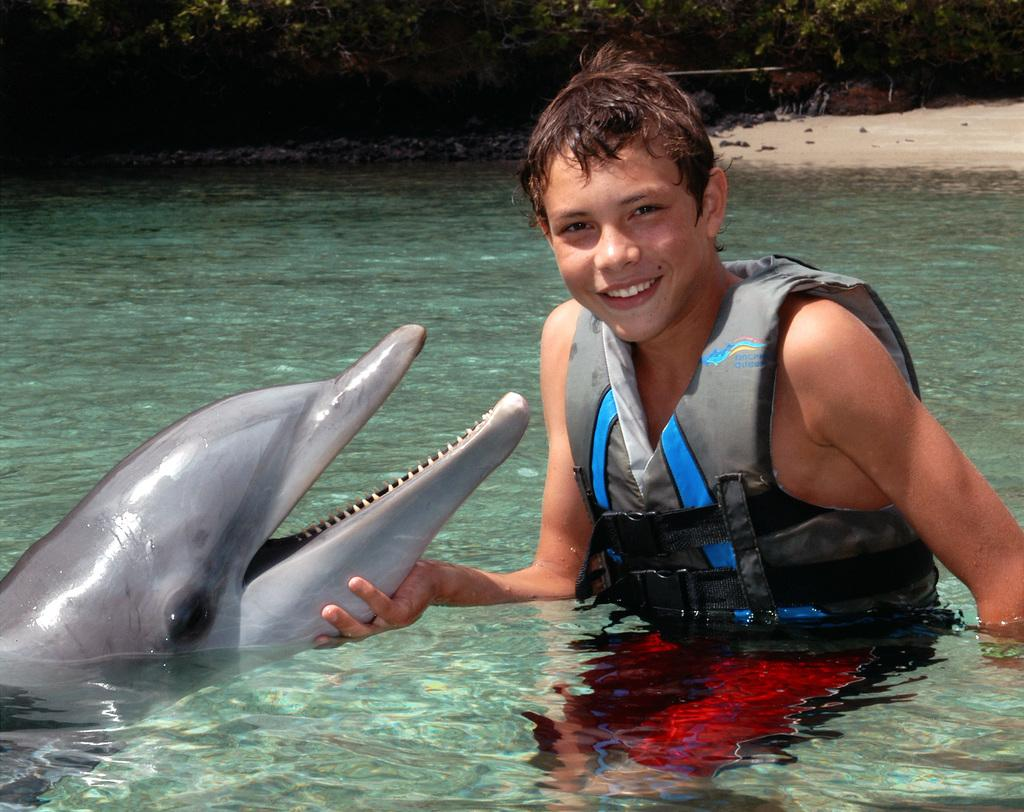Who or what is present in the image? There is a person in the image. What is the person wearing? The person is wearing a jacket. What animal can be seen in the image? There is a dolphin in the image. What type of environment is depicted in the image? There is water at the bottom of the image, and trees and sand in the background. What type of sign can be seen in the image? There is no sign present in the image. Is the person holding a gun in the image? There is no gun present in the image. 